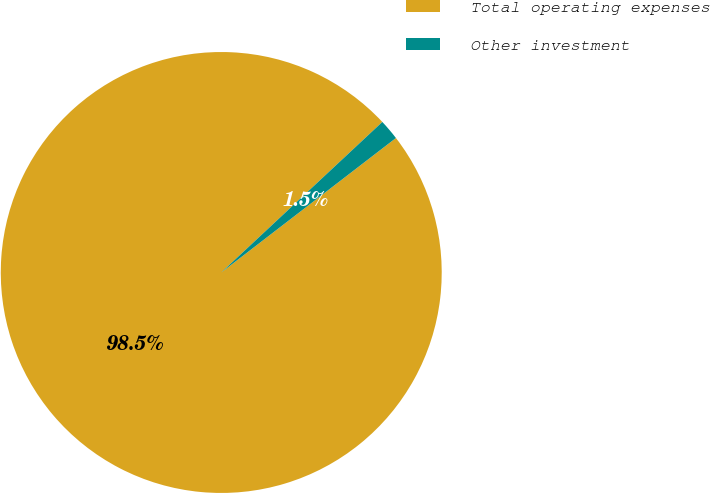<chart> <loc_0><loc_0><loc_500><loc_500><pie_chart><fcel>Total operating expenses<fcel>Other investment<nl><fcel>98.48%<fcel>1.52%<nl></chart> 